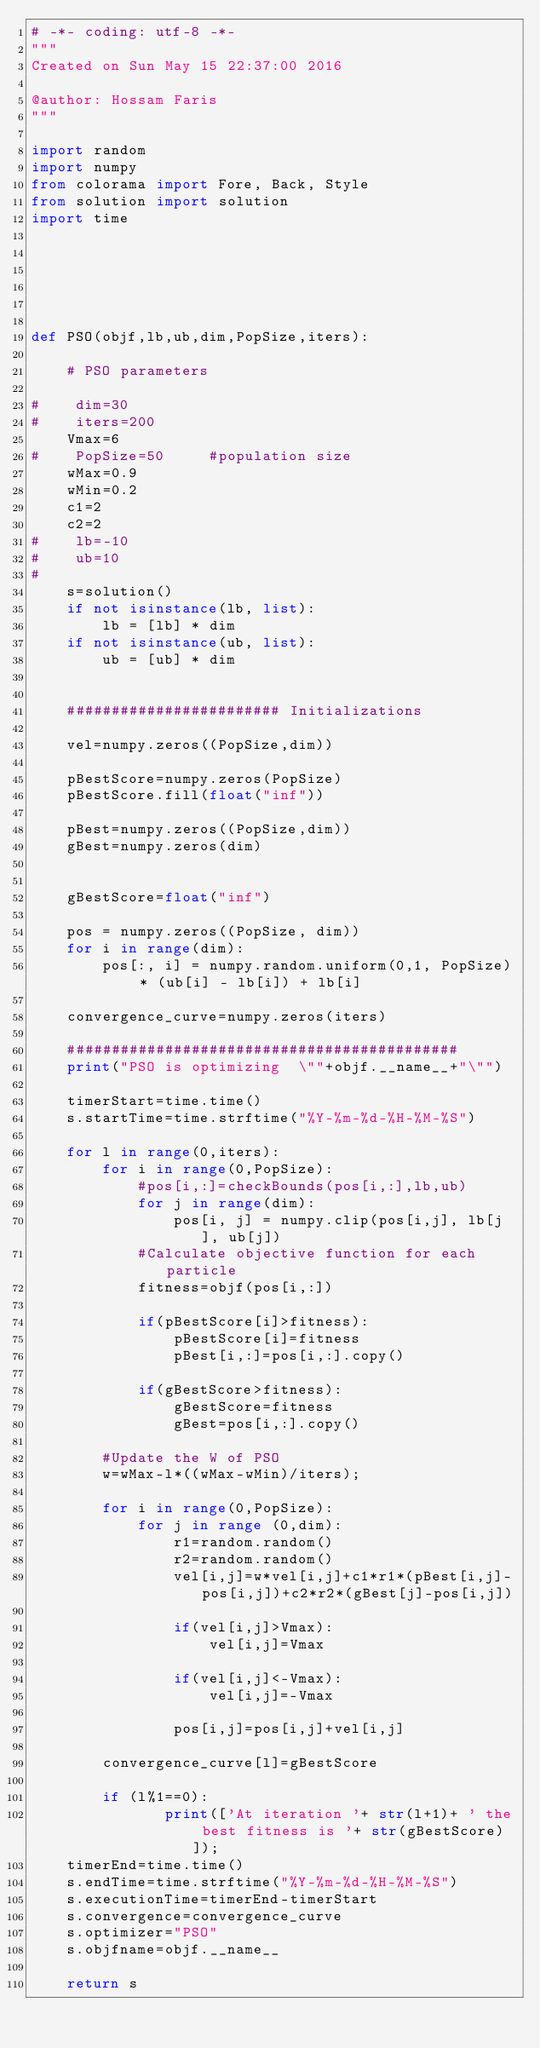<code> <loc_0><loc_0><loc_500><loc_500><_Python_># -*- coding: utf-8 -*-
"""
Created on Sun May 15 22:37:00 2016

@author: Hossam Faris
"""

import random
import numpy
from colorama import Fore, Back, Style
from solution import solution
import time






def PSO(objf,lb,ub,dim,PopSize,iters):

    # PSO parameters
    
#    dim=30
#    iters=200
    Vmax=6
#    PopSize=50     #population size
    wMax=0.9
    wMin=0.2
    c1=2
    c2=2
#    lb=-10
#    ub=10
#    
    s=solution()
    if not isinstance(lb, list):
        lb = [lb] * dim
    if not isinstance(ub, list):
        ub = [ub] * dim
    
    
    ######################## Initializations
    
    vel=numpy.zeros((PopSize,dim))
    
    pBestScore=numpy.zeros(PopSize) 
    pBestScore.fill(float("inf"))
    
    pBest=numpy.zeros((PopSize,dim))
    gBest=numpy.zeros(dim)
    
    
    gBestScore=float("inf")

    pos = numpy.zeros((PopSize, dim))
    for i in range(dim):
        pos[:, i] = numpy.random.uniform(0,1, PopSize) * (ub[i] - lb[i]) + lb[i]
    
    convergence_curve=numpy.zeros(iters)
    
    ############################################
    print("PSO is optimizing  \""+objf.__name__+"\"")    
    
    timerStart=time.time() 
    s.startTime=time.strftime("%Y-%m-%d-%H-%M-%S")
    
    for l in range(0,iters):
        for i in range(0,PopSize):
            #pos[i,:]=checkBounds(pos[i,:],lb,ub)
            for j in range(dim):
                pos[i, j] = numpy.clip(pos[i,j], lb[j], ub[j])
            #Calculate objective function for each particle
            fitness=objf(pos[i,:])
    
            if(pBestScore[i]>fitness):
                pBestScore[i]=fitness
                pBest[i,:]=pos[i,:].copy()
                
            if(gBestScore>fitness):
                gBestScore=fitness
                gBest=pos[i,:].copy()
        
        #Update the W of PSO
        w=wMax-l*((wMax-wMin)/iters);
        
        for i in range(0,PopSize):
            for j in range (0,dim):
                r1=random.random()
                r2=random.random()
                vel[i,j]=w*vel[i,j]+c1*r1*(pBest[i,j]-pos[i,j])+c2*r2*(gBest[j]-pos[i,j])
                
                if(vel[i,j]>Vmax):
                    vel[i,j]=Vmax
                
                if(vel[i,j]<-Vmax):
                    vel[i,j]=-Vmax
                            
                pos[i,j]=pos[i,j]+vel[i,j]
        
        convergence_curve[l]=gBestScore
      
        if (l%1==0):
               print(['At iteration '+ str(l+1)+ ' the best fitness is '+ str(gBestScore)]);
    timerEnd=time.time()  
    s.endTime=time.strftime("%Y-%m-%d-%H-%M-%S")
    s.executionTime=timerEnd-timerStart
    s.convergence=convergence_curve
    s.optimizer="PSO"
    s.objfname=objf.__name__

    return s
         
    
</code> 